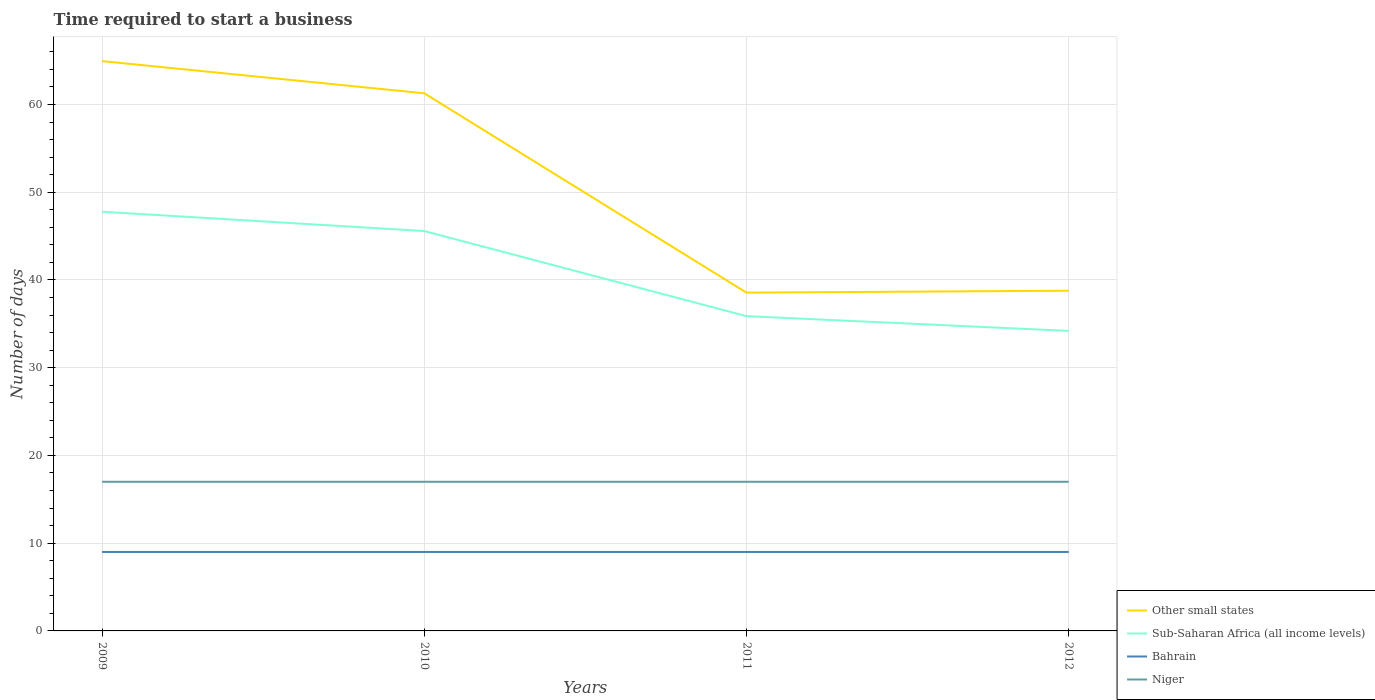Does the line corresponding to Other small states intersect with the line corresponding to Sub-Saharan Africa (all income levels)?
Provide a succinct answer. No. Is the number of lines equal to the number of legend labels?
Offer a very short reply. Yes. Across all years, what is the maximum number of days required to start a business in Sub-Saharan Africa (all income levels)?
Your answer should be very brief. 34.2. What is the total number of days required to start a business in Sub-Saharan Africa (all income levels) in the graph?
Offer a terse response. 1.68. What is the difference between the highest and the lowest number of days required to start a business in Niger?
Offer a very short reply. 0. Is the number of days required to start a business in Bahrain strictly greater than the number of days required to start a business in Sub-Saharan Africa (all income levels) over the years?
Make the answer very short. Yes. How many lines are there?
Ensure brevity in your answer.  4. What is the difference between two consecutive major ticks on the Y-axis?
Your answer should be very brief. 10. Are the values on the major ticks of Y-axis written in scientific E-notation?
Give a very brief answer. No. Does the graph contain grids?
Your answer should be compact. Yes. Where does the legend appear in the graph?
Ensure brevity in your answer.  Bottom right. How are the legend labels stacked?
Your answer should be very brief. Vertical. What is the title of the graph?
Your response must be concise. Time required to start a business. Does "French Polynesia" appear as one of the legend labels in the graph?
Offer a terse response. No. What is the label or title of the Y-axis?
Provide a short and direct response. Number of days. What is the Number of days of Other small states in 2009?
Ensure brevity in your answer.  64.94. What is the Number of days in Sub-Saharan Africa (all income levels) in 2009?
Provide a succinct answer. 47.78. What is the Number of days in Bahrain in 2009?
Make the answer very short. 9. What is the Number of days in Other small states in 2010?
Provide a succinct answer. 61.28. What is the Number of days of Sub-Saharan Africa (all income levels) in 2010?
Provide a succinct answer. 45.58. What is the Number of days of Bahrain in 2010?
Ensure brevity in your answer.  9. What is the Number of days in Other small states in 2011?
Your response must be concise. 38.56. What is the Number of days in Sub-Saharan Africa (all income levels) in 2011?
Your answer should be very brief. 35.88. What is the Number of days of Bahrain in 2011?
Keep it short and to the point. 9. What is the Number of days of Other small states in 2012?
Keep it short and to the point. 38.78. What is the Number of days of Sub-Saharan Africa (all income levels) in 2012?
Your answer should be very brief. 34.2. What is the Number of days in Bahrain in 2012?
Your response must be concise. 9. Across all years, what is the maximum Number of days of Other small states?
Provide a succinct answer. 64.94. Across all years, what is the maximum Number of days in Sub-Saharan Africa (all income levels)?
Offer a very short reply. 47.78. Across all years, what is the minimum Number of days in Other small states?
Your answer should be compact. 38.56. Across all years, what is the minimum Number of days of Sub-Saharan Africa (all income levels)?
Keep it short and to the point. 34.2. Across all years, what is the minimum Number of days in Niger?
Provide a short and direct response. 17. What is the total Number of days of Other small states in the graph?
Provide a short and direct response. 203.56. What is the total Number of days in Sub-Saharan Africa (all income levels) in the graph?
Give a very brief answer. 163.43. What is the difference between the Number of days in Other small states in 2009 and that in 2010?
Your response must be concise. 3.67. What is the difference between the Number of days in Sub-Saharan Africa (all income levels) in 2009 and that in 2010?
Offer a terse response. 2.2. What is the difference between the Number of days of Niger in 2009 and that in 2010?
Offer a terse response. 0. What is the difference between the Number of days of Other small states in 2009 and that in 2011?
Your answer should be compact. 26.39. What is the difference between the Number of days of Bahrain in 2009 and that in 2011?
Give a very brief answer. 0. What is the difference between the Number of days in Other small states in 2009 and that in 2012?
Your response must be concise. 26.17. What is the difference between the Number of days in Sub-Saharan Africa (all income levels) in 2009 and that in 2012?
Offer a very short reply. 13.58. What is the difference between the Number of days in Bahrain in 2009 and that in 2012?
Offer a very short reply. 0. What is the difference between the Number of days of Other small states in 2010 and that in 2011?
Offer a very short reply. 22.72. What is the difference between the Number of days of Bahrain in 2010 and that in 2011?
Make the answer very short. 0. What is the difference between the Number of days of Niger in 2010 and that in 2011?
Your answer should be compact. 0. What is the difference between the Number of days of Other small states in 2010 and that in 2012?
Your answer should be very brief. 22.5. What is the difference between the Number of days of Sub-Saharan Africa (all income levels) in 2010 and that in 2012?
Offer a terse response. 11.38. What is the difference between the Number of days of Bahrain in 2010 and that in 2012?
Provide a short and direct response. 0. What is the difference between the Number of days of Niger in 2010 and that in 2012?
Your response must be concise. 0. What is the difference between the Number of days of Other small states in 2011 and that in 2012?
Keep it short and to the point. -0.22. What is the difference between the Number of days in Sub-Saharan Africa (all income levels) in 2011 and that in 2012?
Your answer should be compact. 1.68. What is the difference between the Number of days in Bahrain in 2011 and that in 2012?
Offer a very short reply. 0. What is the difference between the Number of days of Niger in 2011 and that in 2012?
Make the answer very short. 0. What is the difference between the Number of days of Other small states in 2009 and the Number of days of Sub-Saharan Africa (all income levels) in 2010?
Make the answer very short. 19.37. What is the difference between the Number of days of Other small states in 2009 and the Number of days of Bahrain in 2010?
Your answer should be very brief. 55.94. What is the difference between the Number of days in Other small states in 2009 and the Number of days in Niger in 2010?
Make the answer very short. 47.94. What is the difference between the Number of days of Sub-Saharan Africa (all income levels) in 2009 and the Number of days of Bahrain in 2010?
Provide a succinct answer. 38.78. What is the difference between the Number of days of Sub-Saharan Africa (all income levels) in 2009 and the Number of days of Niger in 2010?
Provide a succinct answer. 30.78. What is the difference between the Number of days in Other small states in 2009 and the Number of days in Sub-Saharan Africa (all income levels) in 2011?
Give a very brief answer. 29.07. What is the difference between the Number of days of Other small states in 2009 and the Number of days of Bahrain in 2011?
Make the answer very short. 55.94. What is the difference between the Number of days of Other small states in 2009 and the Number of days of Niger in 2011?
Offer a very short reply. 47.94. What is the difference between the Number of days in Sub-Saharan Africa (all income levels) in 2009 and the Number of days in Bahrain in 2011?
Provide a succinct answer. 38.78. What is the difference between the Number of days in Sub-Saharan Africa (all income levels) in 2009 and the Number of days in Niger in 2011?
Make the answer very short. 30.78. What is the difference between the Number of days of Bahrain in 2009 and the Number of days of Niger in 2011?
Your answer should be very brief. -8. What is the difference between the Number of days in Other small states in 2009 and the Number of days in Sub-Saharan Africa (all income levels) in 2012?
Offer a very short reply. 30.75. What is the difference between the Number of days of Other small states in 2009 and the Number of days of Bahrain in 2012?
Your response must be concise. 55.94. What is the difference between the Number of days of Other small states in 2009 and the Number of days of Niger in 2012?
Ensure brevity in your answer.  47.94. What is the difference between the Number of days of Sub-Saharan Africa (all income levels) in 2009 and the Number of days of Bahrain in 2012?
Provide a succinct answer. 38.78. What is the difference between the Number of days of Sub-Saharan Africa (all income levels) in 2009 and the Number of days of Niger in 2012?
Give a very brief answer. 30.78. What is the difference between the Number of days in Other small states in 2010 and the Number of days in Sub-Saharan Africa (all income levels) in 2011?
Provide a succinct answer. 25.4. What is the difference between the Number of days of Other small states in 2010 and the Number of days of Bahrain in 2011?
Your answer should be compact. 52.28. What is the difference between the Number of days of Other small states in 2010 and the Number of days of Niger in 2011?
Keep it short and to the point. 44.28. What is the difference between the Number of days of Sub-Saharan Africa (all income levels) in 2010 and the Number of days of Bahrain in 2011?
Offer a very short reply. 36.58. What is the difference between the Number of days of Sub-Saharan Africa (all income levels) in 2010 and the Number of days of Niger in 2011?
Offer a terse response. 28.58. What is the difference between the Number of days of Bahrain in 2010 and the Number of days of Niger in 2011?
Your answer should be very brief. -8. What is the difference between the Number of days in Other small states in 2010 and the Number of days in Sub-Saharan Africa (all income levels) in 2012?
Give a very brief answer. 27.08. What is the difference between the Number of days of Other small states in 2010 and the Number of days of Bahrain in 2012?
Your answer should be very brief. 52.28. What is the difference between the Number of days in Other small states in 2010 and the Number of days in Niger in 2012?
Your response must be concise. 44.28. What is the difference between the Number of days in Sub-Saharan Africa (all income levels) in 2010 and the Number of days in Bahrain in 2012?
Provide a short and direct response. 36.58. What is the difference between the Number of days of Sub-Saharan Africa (all income levels) in 2010 and the Number of days of Niger in 2012?
Give a very brief answer. 28.58. What is the difference between the Number of days of Other small states in 2011 and the Number of days of Sub-Saharan Africa (all income levels) in 2012?
Your response must be concise. 4.36. What is the difference between the Number of days of Other small states in 2011 and the Number of days of Bahrain in 2012?
Give a very brief answer. 29.56. What is the difference between the Number of days in Other small states in 2011 and the Number of days in Niger in 2012?
Provide a short and direct response. 21.56. What is the difference between the Number of days of Sub-Saharan Africa (all income levels) in 2011 and the Number of days of Bahrain in 2012?
Make the answer very short. 26.88. What is the difference between the Number of days in Sub-Saharan Africa (all income levels) in 2011 and the Number of days in Niger in 2012?
Your response must be concise. 18.88. What is the average Number of days of Other small states per year?
Your answer should be compact. 50.89. What is the average Number of days of Sub-Saharan Africa (all income levels) per year?
Your response must be concise. 40.86. What is the average Number of days in Niger per year?
Provide a short and direct response. 17. In the year 2009, what is the difference between the Number of days of Other small states and Number of days of Sub-Saharan Africa (all income levels)?
Your response must be concise. 17.17. In the year 2009, what is the difference between the Number of days in Other small states and Number of days in Bahrain?
Keep it short and to the point. 55.94. In the year 2009, what is the difference between the Number of days of Other small states and Number of days of Niger?
Provide a short and direct response. 47.94. In the year 2009, what is the difference between the Number of days in Sub-Saharan Africa (all income levels) and Number of days in Bahrain?
Offer a very short reply. 38.78. In the year 2009, what is the difference between the Number of days of Sub-Saharan Africa (all income levels) and Number of days of Niger?
Provide a short and direct response. 30.78. In the year 2010, what is the difference between the Number of days of Other small states and Number of days of Bahrain?
Your answer should be compact. 52.28. In the year 2010, what is the difference between the Number of days in Other small states and Number of days in Niger?
Offer a terse response. 44.28. In the year 2010, what is the difference between the Number of days in Sub-Saharan Africa (all income levels) and Number of days in Bahrain?
Give a very brief answer. 36.58. In the year 2010, what is the difference between the Number of days in Sub-Saharan Africa (all income levels) and Number of days in Niger?
Provide a succinct answer. 28.58. In the year 2010, what is the difference between the Number of days in Bahrain and Number of days in Niger?
Keep it short and to the point. -8. In the year 2011, what is the difference between the Number of days in Other small states and Number of days in Sub-Saharan Africa (all income levels)?
Give a very brief answer. 2.68. In the year 2011, what is the difference between the Number of days in Other small states and Number of days in Bahrain?
Give a very brief answer. 29.56. In the year 2011, what is the difference between the Number of days in Other small states and Number of days in Niger?
Make the answer very short. 21.56. In the year 2011, what is the difference between the Number of days in Sub-Saharan Africa (all income levels) and Number of days in Bahrain?
Keep it short and to the point. 26.88. In the year 2011, what is the difference between the Number of days of Sub-Saharan Africa (all income levels) and Number of days of Niger?
Offer a very short reply. 18.88. In the year 2011, what is the difference between the Number of days in Bahrain and Number of days in Niger?
Make the answer very short. -8. In the year 2012, what is the difference between the Number of days in Other small states and Number of days in Sub-Saharan Africa (all income levels)?
Your answer should be very brief. 4.58. In the year 2012, what is the difference between the Number of days of Other small states and Number of days of Bahrain?
Make the answer very short. 29.78. In the year 2012, what is the difference between the Number of days of Other small states and Number of days of Niger?
Offer a terse response. 21.78. In the year 2012, what is the difference between the Number of days of Sub-Saharan Africa (all income levels) and Number of days of Bahrain?
Make the answer very short. 25.2. In the year 2012, what is the difference between the Number of days in Sub-Saharan Africa (all income levels) and Number of days in Niger?
Make the answer very short. 17.2. What is the ratio of the Number of days of Other small states in 2009 to that in 2010?
Offer a very short reply. 1.06. What is the ratio of the Number of days in Sub-Saharan Africa (all income levels) in 2009 to that in 2010?
Offer a very short reply. 1.05. What is the ratio of the Number of days in Bahrain in 2009 to that in 2010?
Ensure brevity in your answer.  1. What is the ratio of the Number of days of Other small states in 2009 to that in 2011?
Offer a terse response. 1.68. What is the ratio of the Number of days in Sub-Saharan Africa (all income levels) in 2009 to that in 2011?
Your answer should be very brief. 1.33. What is the ratio of the Number of days of Bahrain in 2009 to that in 2011?
Give a very brief answer. 1. What is the ratio of the Number of days of Other small states in 2009 to that in 2012?
Offer a terse response. 1.67. What is the ratio of the Number of days of Sub-Saharan Africa (all income levels) in 2009 to that in 2012?
Offer a very short reply. 1.4. What is the ratio of the Number of days in Bahrain in 2009 to that in 2012?
Ensure brevity in your answer.  1. What is the ratio of the Number of days in Niger in 2009 to that in 2012?
Offer a terse response. 1. What is the ratio of the Number of days in Other small states in 2010 to that in 2011?
Offer a terse response. 1.59. What is the ratio of the Number of days in Sub-Saharan Africa (all income levels) in 2010 to that in 2011?
Offer a terse response. 1.27. What is the ratio of the Number of days in Bahrain in 2010 to that in 2011?
Offer a terse response. 1. What is the ratio of the Number of days of Other small states in 2010 to that in 2012?
Provide a succinct answer. 1.58. What is the ratio of the Number of days in Sub-Saharan Africa (all income levels) in 2010 to that in 2012?
Provide a short and direct response. 1.33. What is the ratio of the Number of days of Niger in 2010 to that in 2012?
Your response must be concise. 1. What is the ratio of the Number of days in Sub-Saharan Africa (all income levels) in 2011 to that in 2012?
Provide a succinct answer. 1.05. What is the ratio of the Number of days of Bahrain in 2011 to that in 2012?
Provide a succinct answer. 1. What is the difference between the highest and the second highest Number of days in Other small states?
Your answer should be very brief. 3.67. What is the difference between the highest and the lowest Number of days in Other small states?
Offer a very short reply. 26.39. What is the difference between the highest and the lowest Number of days of Sub-Saharan Africa (all income levels)?
Keep it short and to the point. 13.58. 